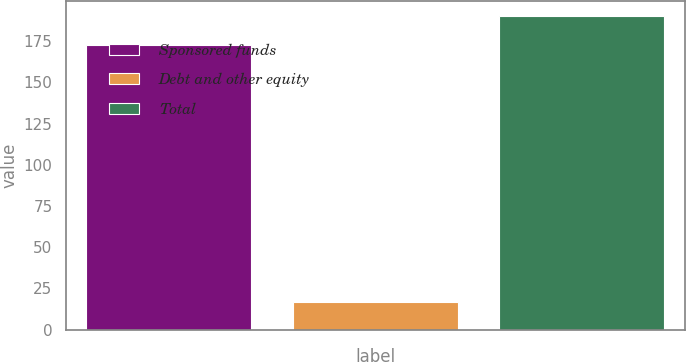Convert chart to OTSL. <chart><loc_0><loc_0><loc_500><loc_500><bar_chart><fcel>Sponsored funds<fcel>Debt and other equity<fcel>Total<nl><fcel>172.9<fcel>16.8<fcel>190.19<nl></chart> 